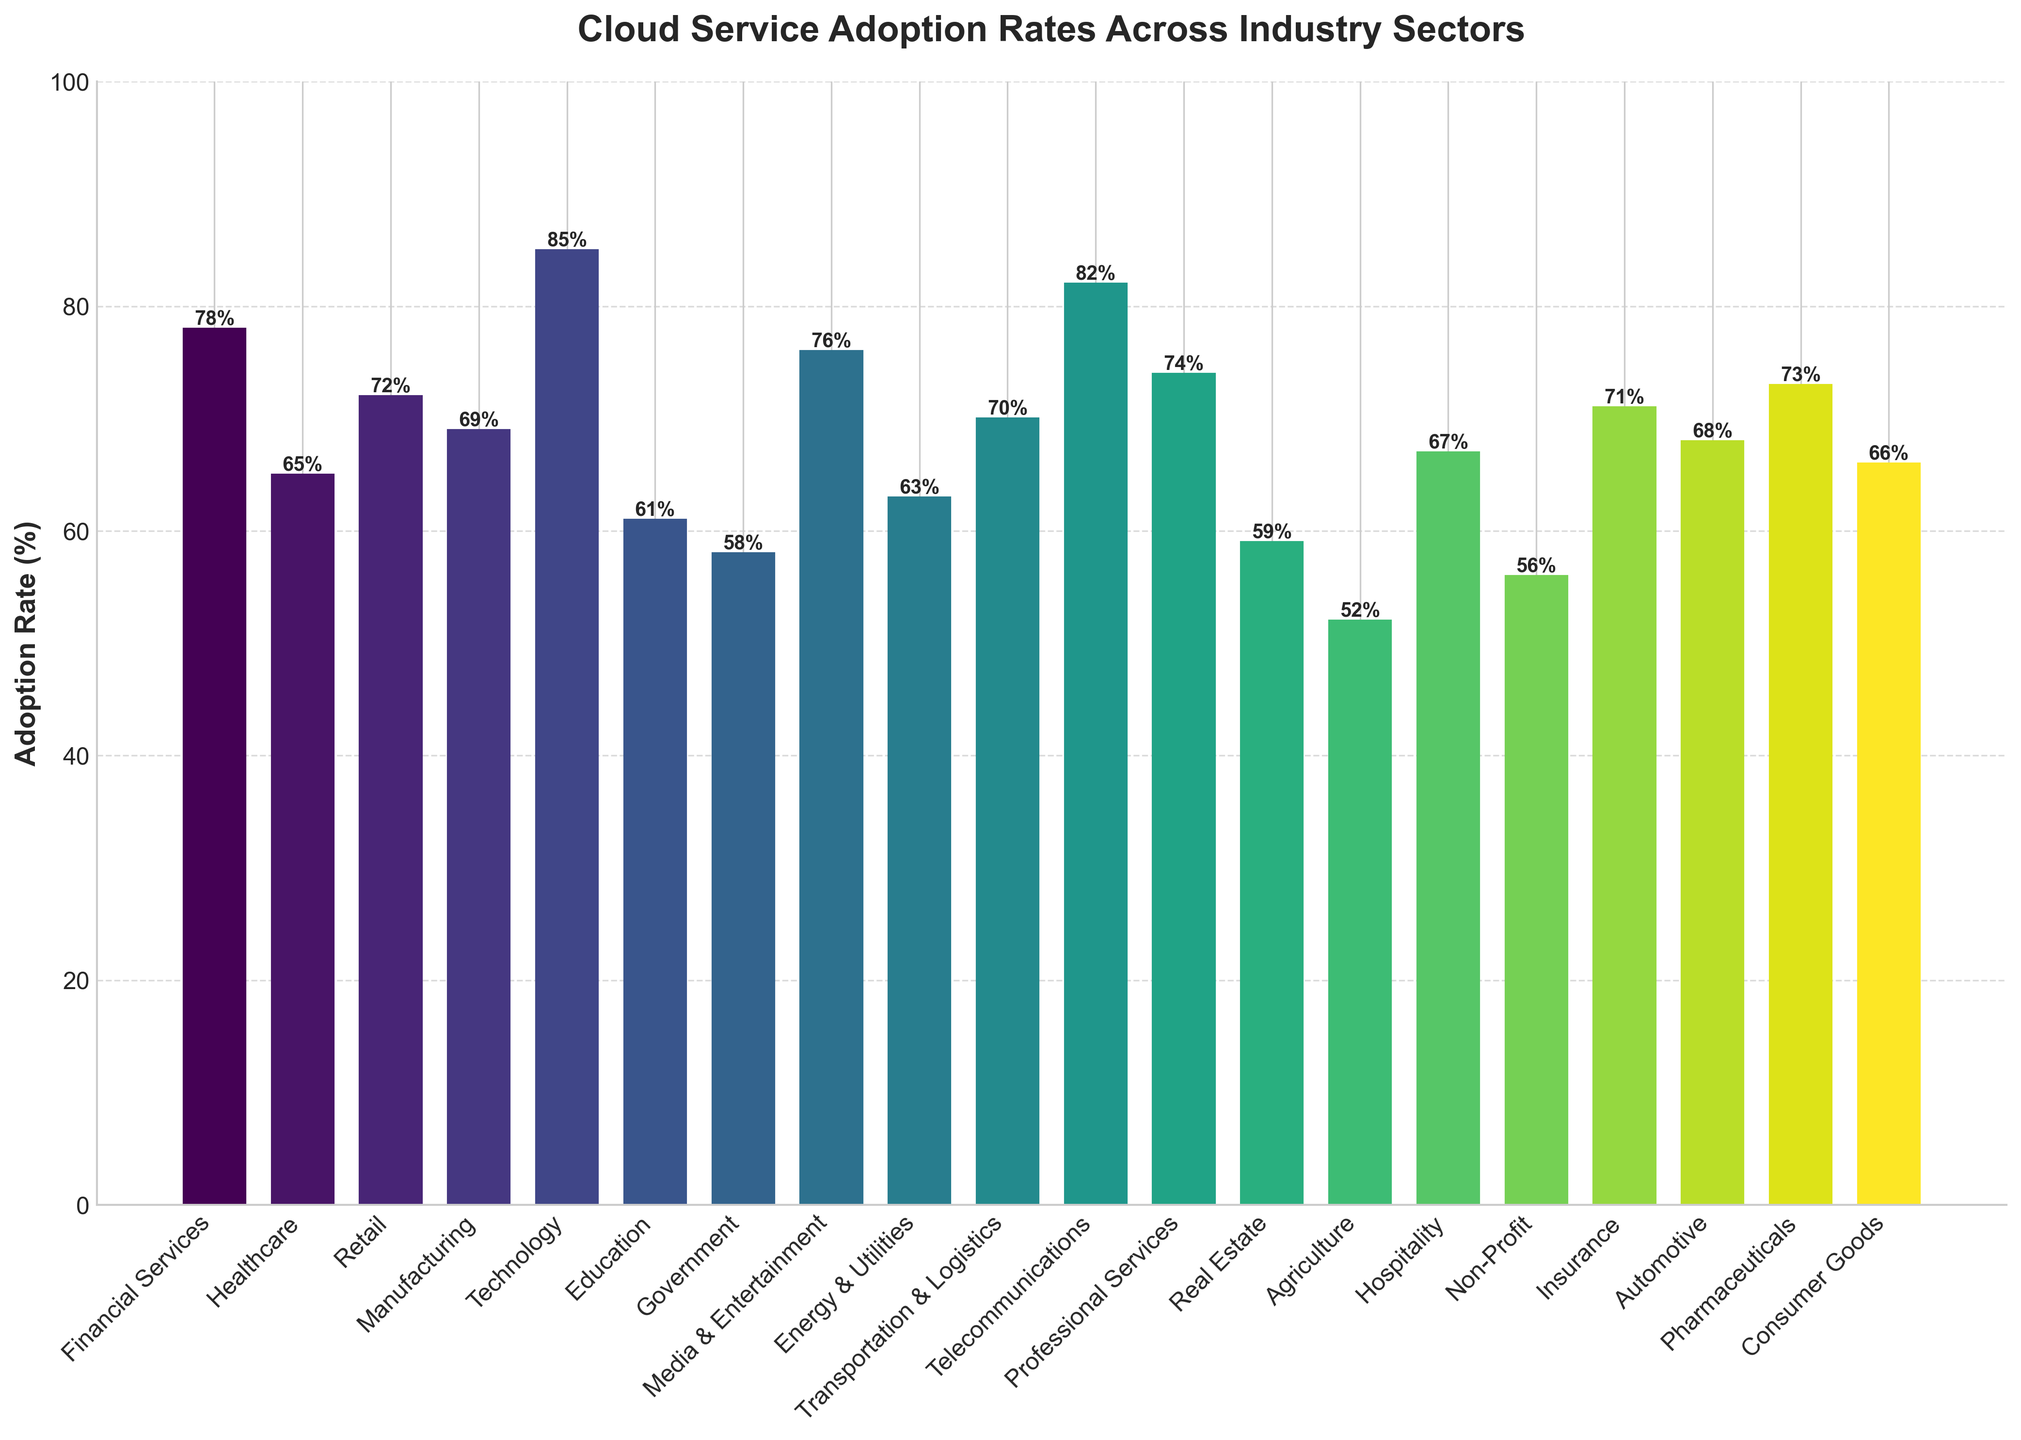Which industry has the highest cloud service adoption rate? The bar chart shows various industries with their respective adoption rates; the highest bar appears for the Technology sector.
Answer: Technology Which two industries have the lowest and second-lowest adoption rates? The bars representing the adoption rates reveal that Agriculture has the lowest rate, followed by Non-Profit.
Answer: Agriculture and Non-Profit How many industries have an adoption rate of 70% or higher? By counting the bars that reach or exceed the 70% mark, we find: Financial Services, Retail, Technology, Media & Entertainment, Transportation & Logistics, Telecommunications, Professional Services, Insurance, Pharmaceuticals.
Answer: 9 What is the difference in the adoption rates between Education and Government sectors? The bar chart shows 61% adoption for Education and 58% for Government. Subtracting 58 from 61 gives the difference.
Answer: 3% Which industry has an adoption rate closest to the median value of all industries? Sorting the adoption rates, the median (middle value) is 68%. The Automotive industry, with an adoption rate of 68%, matches this value.
Answer: Automotive Which industries have adoption rates between 60% and 70%? Checking the chart, industries within this range are: Healthcare, Manufacturing, Education, Energy & Utilities, Real Estate, Hospitality, Automotive, Consumer Goods.
Answer: Healthcare, Manufacturing, Education, Energy & Utilities, Real Estate, Hospitality, Automotive, Consumer Goods How does the adoption rate of Telecommunications compare to Financial Services? The bar chart shows Telecommunications at 82% and Financial Services at 78%, indicating that Telecommunications has a higher adoption rate.
Answer: Telecommunications is higher What is the combined adoption rate of the top three industries? Adding the adoption rates of the top three (Technology at 85%, Telecommunications at 82%, Financial Services at 78%), we get: 85 + 82 + 78 = 245%.
Answer: 245% What visual color pattern is used to differentiate among the bars? Observing the bars, a gradient color pattern from a lighter to darker shade of a single color scheme is applied.
Answer: Gradient pattern 